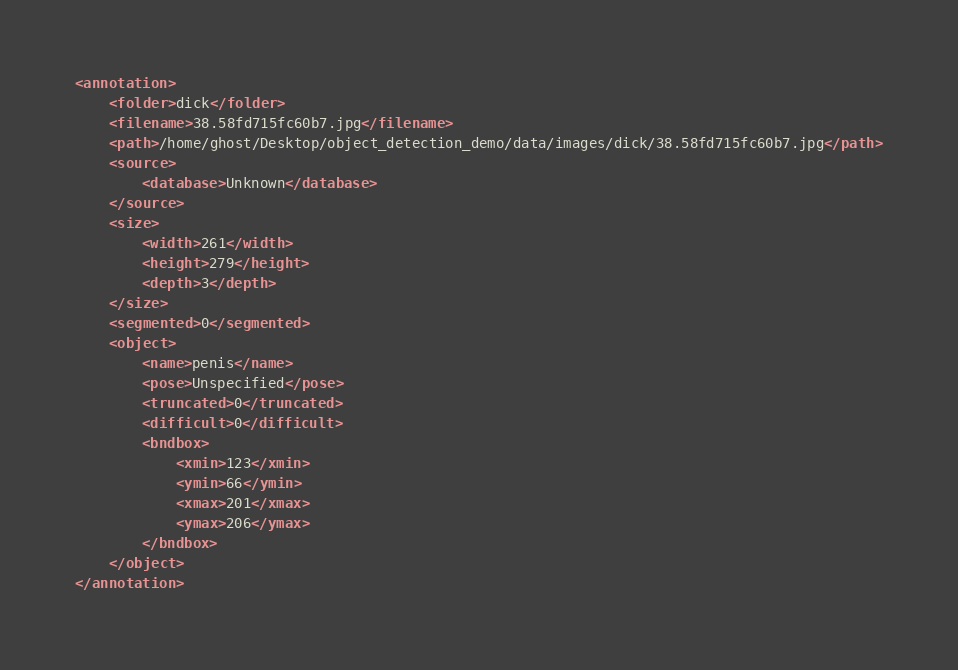<code> <loc_0><loc_0><loc_500><loc_500><_XML_><annotation>
	<folder>dick</folder>
	<filename>38.58fd715fc60b7.jpg</filename>
	<path>/home/ghost/Desktop/object_detection_demo/data/images/dick/38.58fd715fc60b7.jpg</path>
	<source>
		<database>Unknown</database>
	</source>
	<size>
		<width>261</width>
		<height>279</height>
		<depth>3</depth>
	</size>
	<segmented>0</segmented>
	<object>
		<name>penis</name>
		<pose>Unspecified</pose>
		<truncated>0</truncated>
		<difficult>0</difficult>
		<bndbox>
			<xmin>123</xmin>
			<ymin>66</ymin>
			<xmax>201</xmax>
			<ymax>206</ymax>
		</bndbox>
	</object>
</annotation>
</code> 